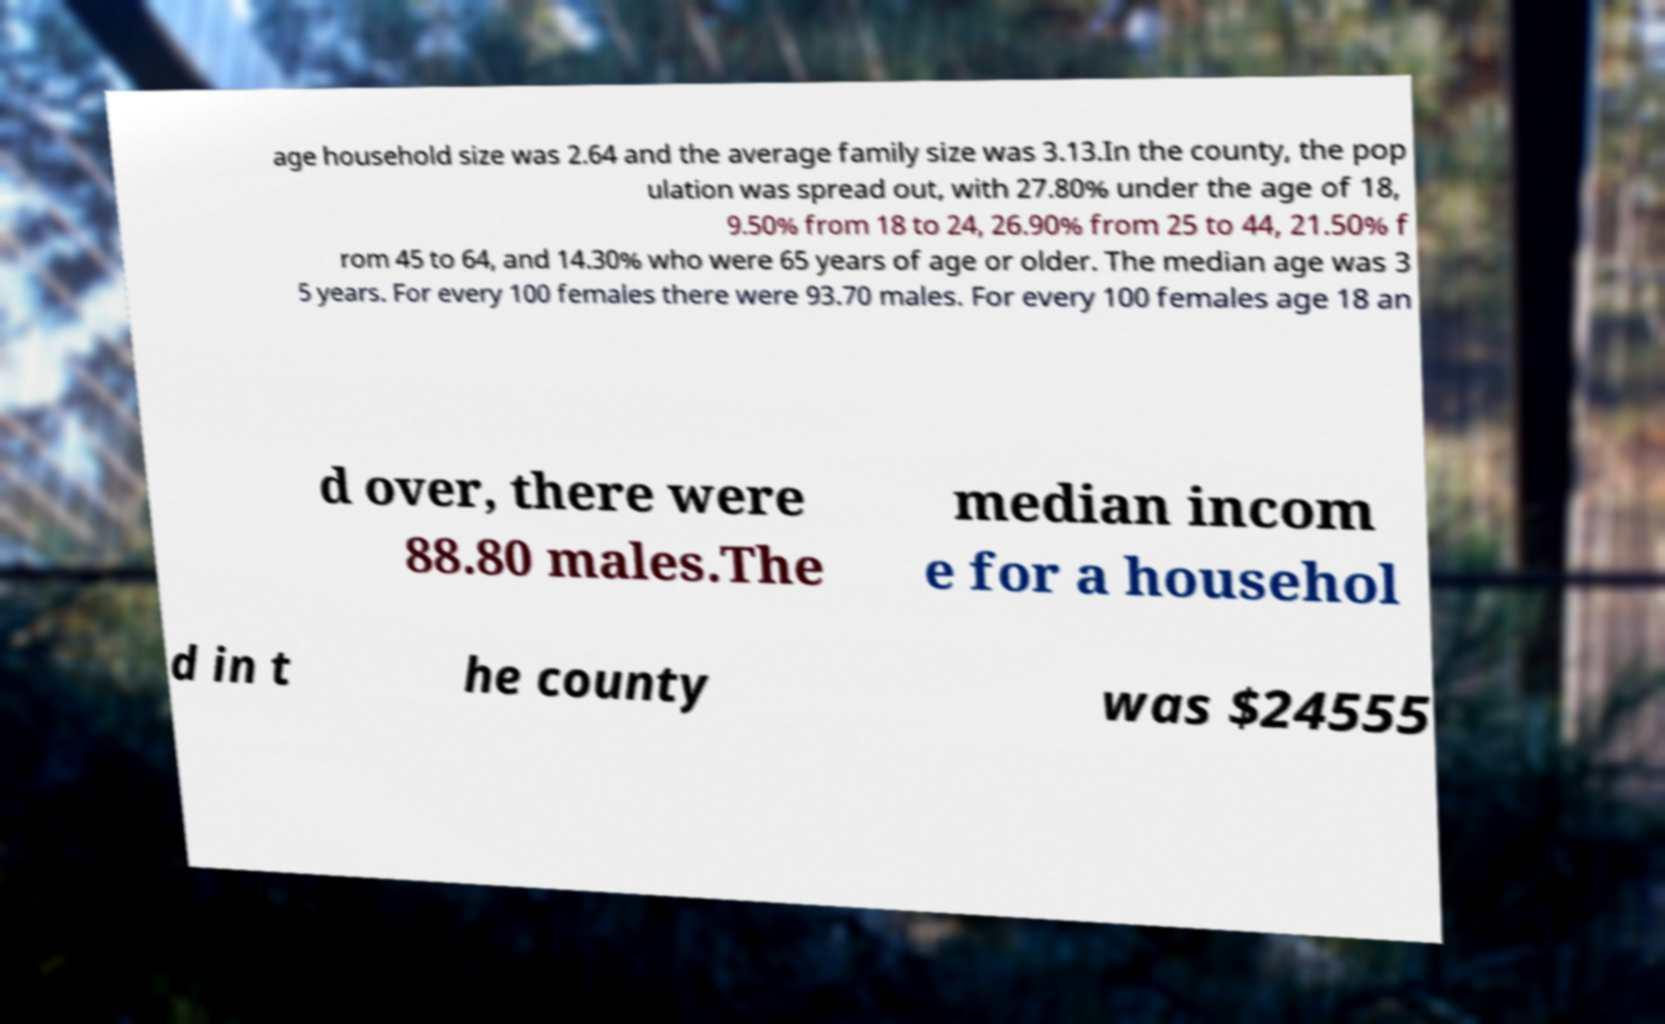What messages or text are displayed in this image? I need them in a readable, typed format. age household size was 2.64 and the average family size was 3.13.In the county, the pop ulation was spread out, with 27.80% under the age of 18, 9.50% from 18 to 24, 26.90% from 25 to 44, 21.50% f rom 45 to 64, and 14.30% who were 65 years of age or older. The median age was 3 5 years. For every 100 females there were 93.70 males. For every 100 females age 18 an d over, there were 88.80 males.The median incom e for a househol d in t he county was $24555 